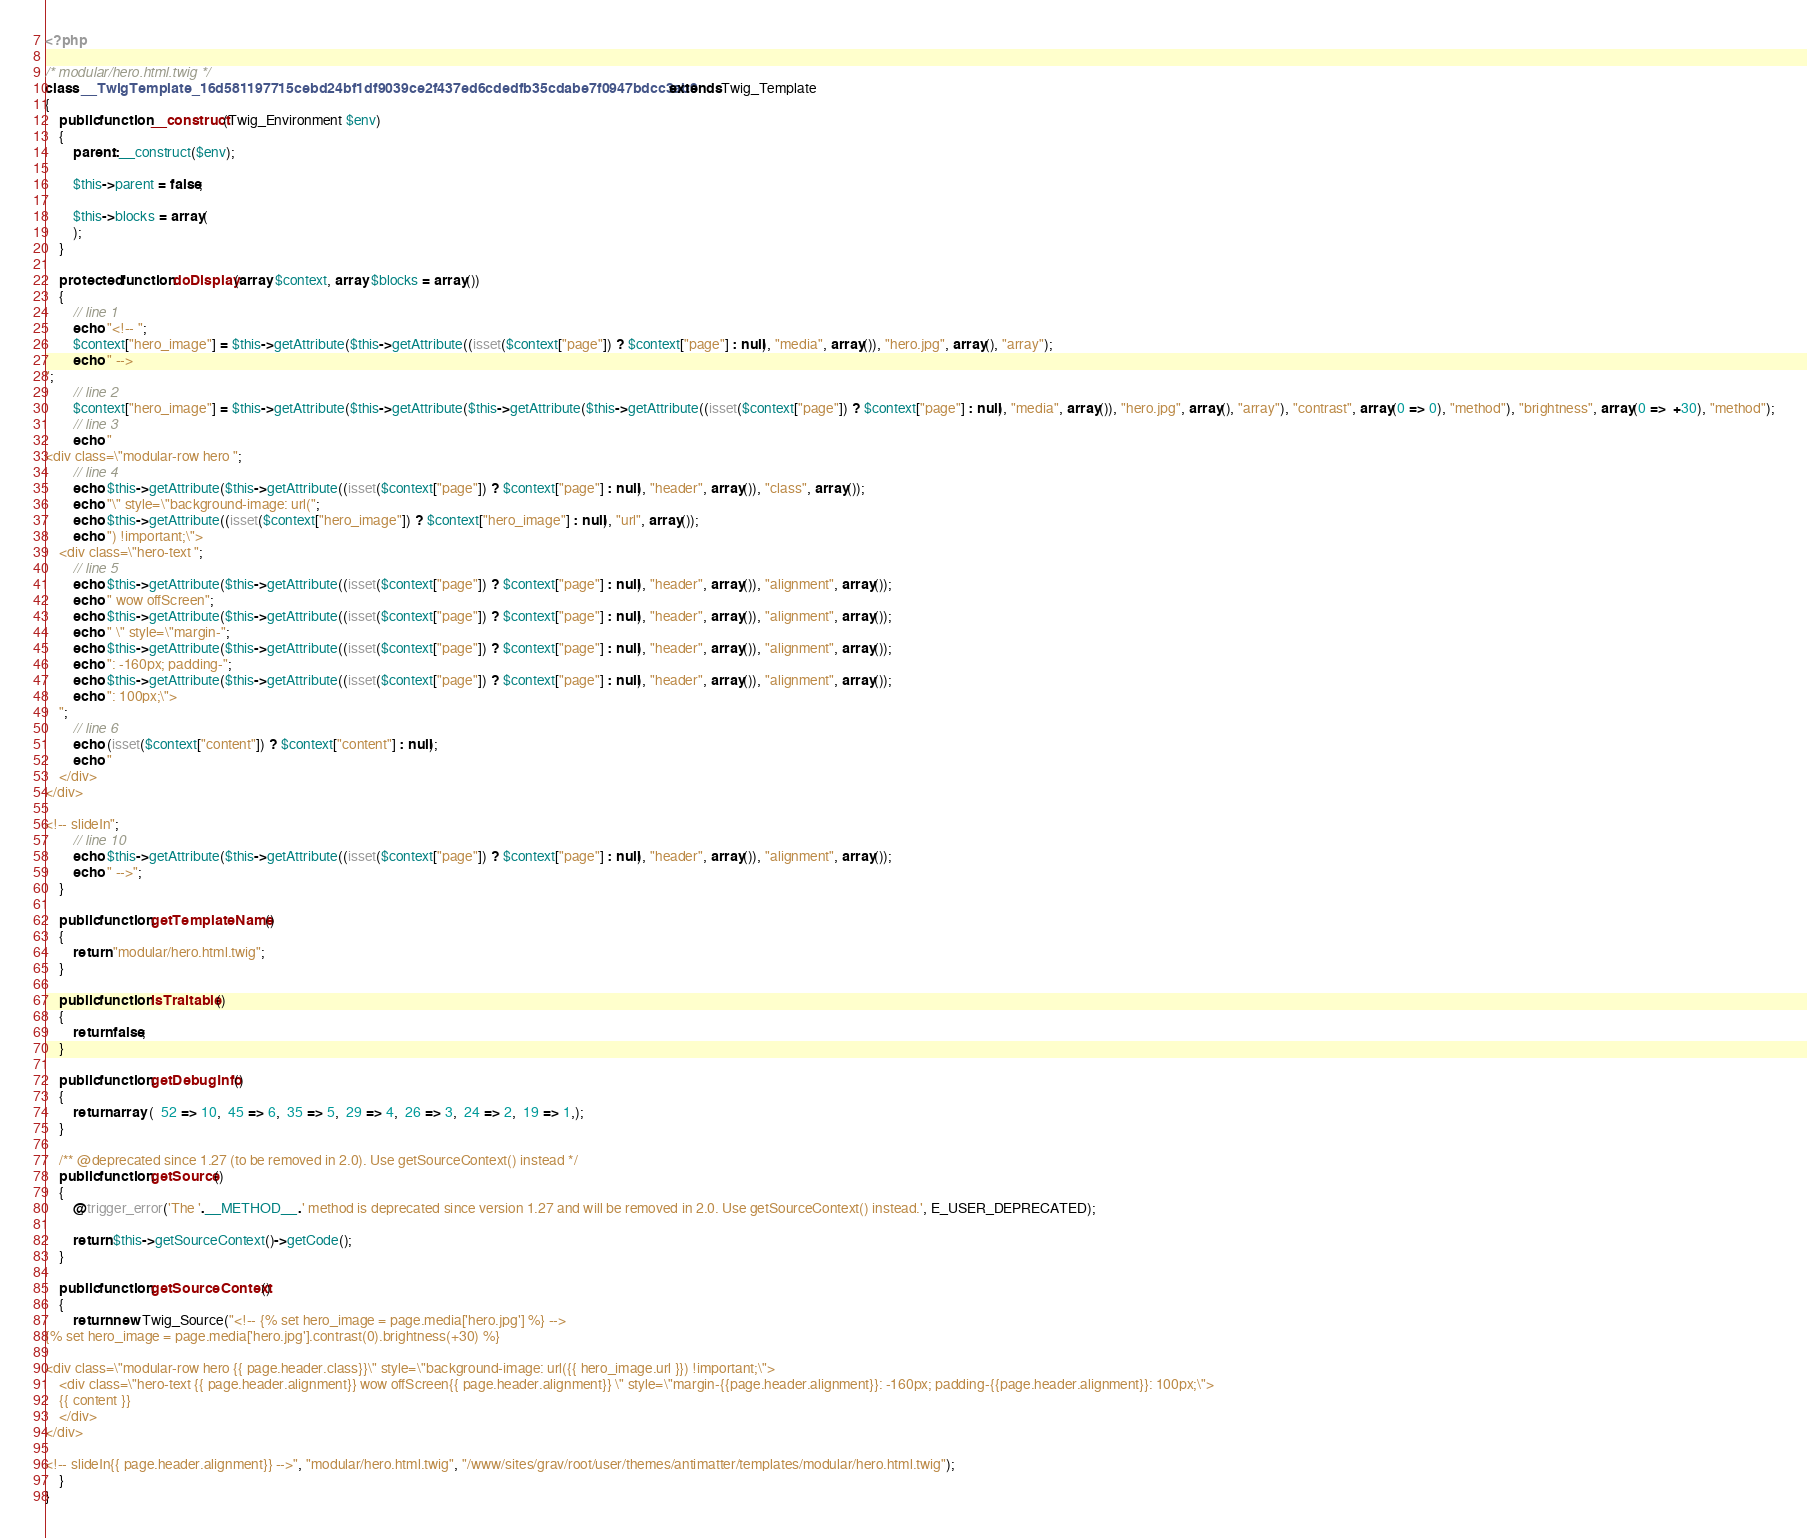Convert code to text. <code><loc_0><loc_0><loc_500><loc_500><_PHP_><?php

/* modular/hero.html.twig */
class __TwigTemplate_16d581197715cebd24bf1df9039ce2f437ed6cdedfb35cdabe7f0947bdcc3ab9 extends Twig_Template
{
    public function __construct(Twig_Environment $env)
    {
        parent::__construct($env);

        $this->parent = false;

        $this->blocks = array(
        );
    }

    protected function doDisplay(array $context, array $blocks = array())
    {
        // line 1
        echo "<!-- ";
        $context["hero_image"] = $this->getAttribute($this->getAttribute((isset($context["page"]) ? $context["page"] : null), "media", array()), "hero.jpg", array(), "array");
        echo " -->
";
        // line 2
        $context["hero_image"] = $this->getAttribute($this->getAttribute($this->getAttribute($this->getAttribute((isset($context["page"]) ? $context["page"] : null), "media", array()), "hero.jpg", array(), "array"), "contrast", array(0 => 0), "method"), "brightness", array(0 =>  +30), "method");
        // line 3
        echo "
<div class=\"modular-row hero ";
        // line 4
        echo $this->getAttribute($this->getAttribute((isset($context["page"]) ? $context["page"] : null), "header", array()), "class", array());
        echo "\" style=\"background-image: url(";
        echo $this->getAttribute((isset($context["hero_image"]) ? $context["hero_image"] : null), "url", array());
        echo ") !important;\">
    <div class=\"hero-text ";
        // line 5
        echo $this->getAttribute($this->getAttribute((isset($context["page"]) ? $context["page"] : null), "header", array()), "alignment", array());
        echo " wow offScreen";
        echo $this->getAttribute($this->getAttribute((isset($context["page"]) ? $context["page"] : null), "header", array()), "alignment", array());
        echo " \" style=\"margin-";
        echo $this->getAttribute($this->getAttribute((isset($context["page"]) ? $context["page"] : null), "header", array()), "alignment", array());
        echo ": -160px; padding-";
        echo $this->getAttribute($this->getAttribute((isset($context["page"]) ? $context["page"] : null), "header", array()), "alignment", array());
        echo ": 100px;\">
    ";
        // line 6
        echo (isset($context["content"]) ? $context["content"] : null);
        echo "
    </div>
</div>

<!-- slideIn";
        // line 10
        echo $this->getAttribute($this->getAttribute((isset($context["page"]) ? $context["page"] : null), "header", array()), "alignment", array());
        echo " -->";
    }

    public function getTemplateName()
    {
        return "modular/hero.html.twig";
    }

    public function isTraitable()
    {
        return false;
    }

    public function getDebugInfo()
    {
        return array (  52 => 10,  45 => 6,  35 => 5,  29 => 4,  26 => 3,  24 => 2,  19 => 1,);
    }

    /** @deprecated since 1.27 (to be removed in 2.0). Use getSourceContext() instead */
    public function getSource()
    {
        @trigger_error('The '.__METHOD__.' method is deprecated since version 1.27 and will be removed in 2.0. Use getSourceContext() instead.', E_USER_DEPRECATED);

        return $this->getSourceContext()->getCode();
    }

    public function getSourceContext()
    {
        return new Twig_Source("<!-- {% set hero_image = page.media['hero.jpg'] %} -->
{% set hero_image = page.media['hero.jpg'].contrast(0).brightness(+30) %}

<div class=\"modular-row hero {{ page.header.class}}\" style=\"background-image: url({{ hero_image.url }}) !important;\">
    <div class=\"hero-text {{ page.header.alignment}} wow offScreen{{ page.header.alignment}} \" style=\"margin-{{page.header.alignment}}: -160px; padding-{{page.header.alignment}}: 100px;\">
    {{ content }}
    </div>
</div>

<!-- slideIn{{ page.header.alignment}} -->", "modular/hero.html.twig", "/www/sites/grav/root/user/themes/antimatter/templates/modular/hero.html.twig");
    }
}
</code> 